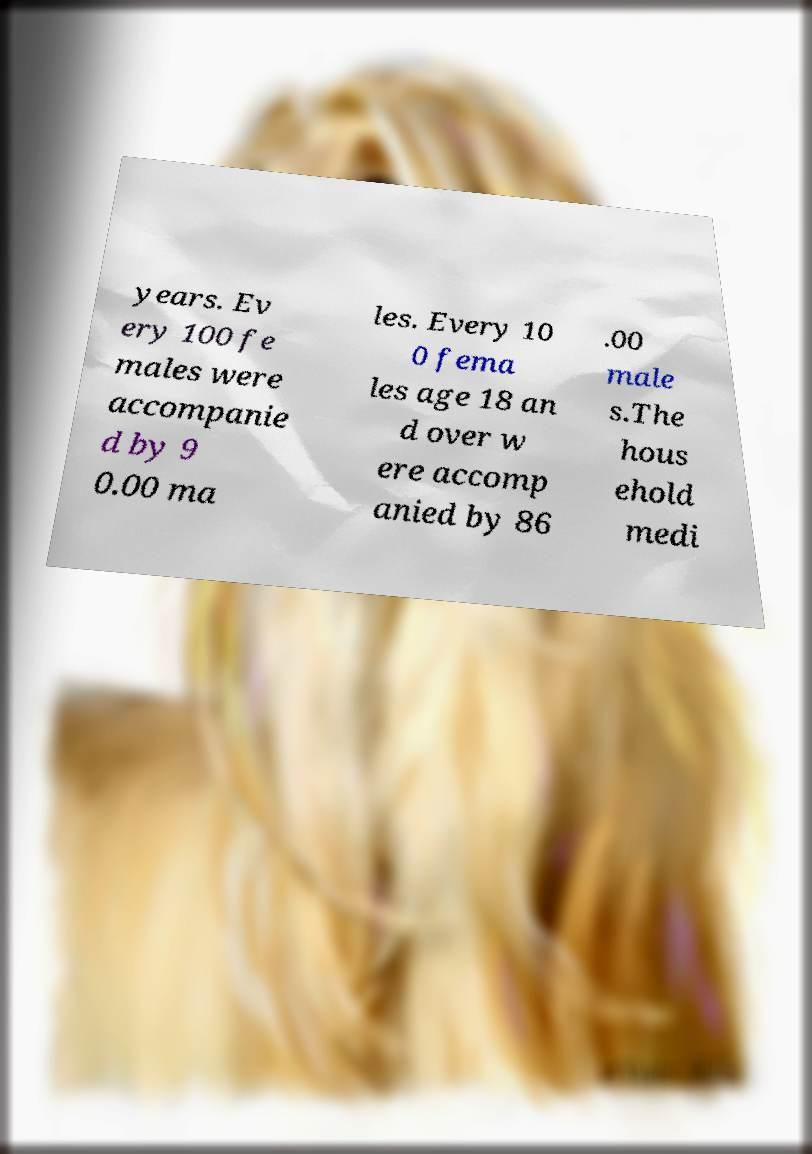What messages or text are displayed in this image? I need them in a readable, typed format. years. Ev ery 100 fe males were accompanie d by 9 0.00 ma les. Every 10 0 fema les age 18 an d over w ere accomp anied by 86 .00 male s.The hous ehold medi 